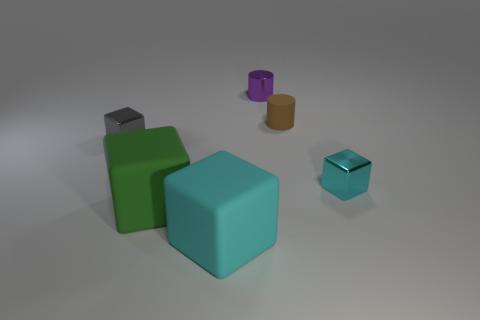Add 4 small gray objects. How many objects exist? 10 Subtract all cylinders. How many objects are left? 4 Subtract all big cyan things. Subtract all big rubber objects. How many objects are left? 3 Add 3 small metallic cubes. How many small metallic cubes are left? 5 Add 6 big brown matte balls. How many big brown matte balls exist? 6 Subtract 0 blue blocks. How many objects are left? 6 